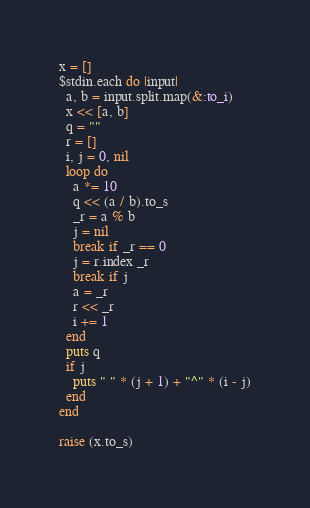Convert code to text. <code><loc_0><loc_0><loc_500><loc_500><_Ruby_>x = []
$stdin.each do |input|
  a, b = input.split.map(&:to_i)
  x << [a, b]
  q = ""
  r = []
  i, j = 0, nil
  loop do
    a *= 10
    q << (a / b).to_s
    _r = a % b
    j = nil
    break if _r == 0
    j = r.index _r
    break if j
    a = _r
    r << _r
    i += 1
  end
  puts q
  if j
    puts " " * (j + 1) + "^" * (i - j)
  end
end

raise (x.to_s)</code> 